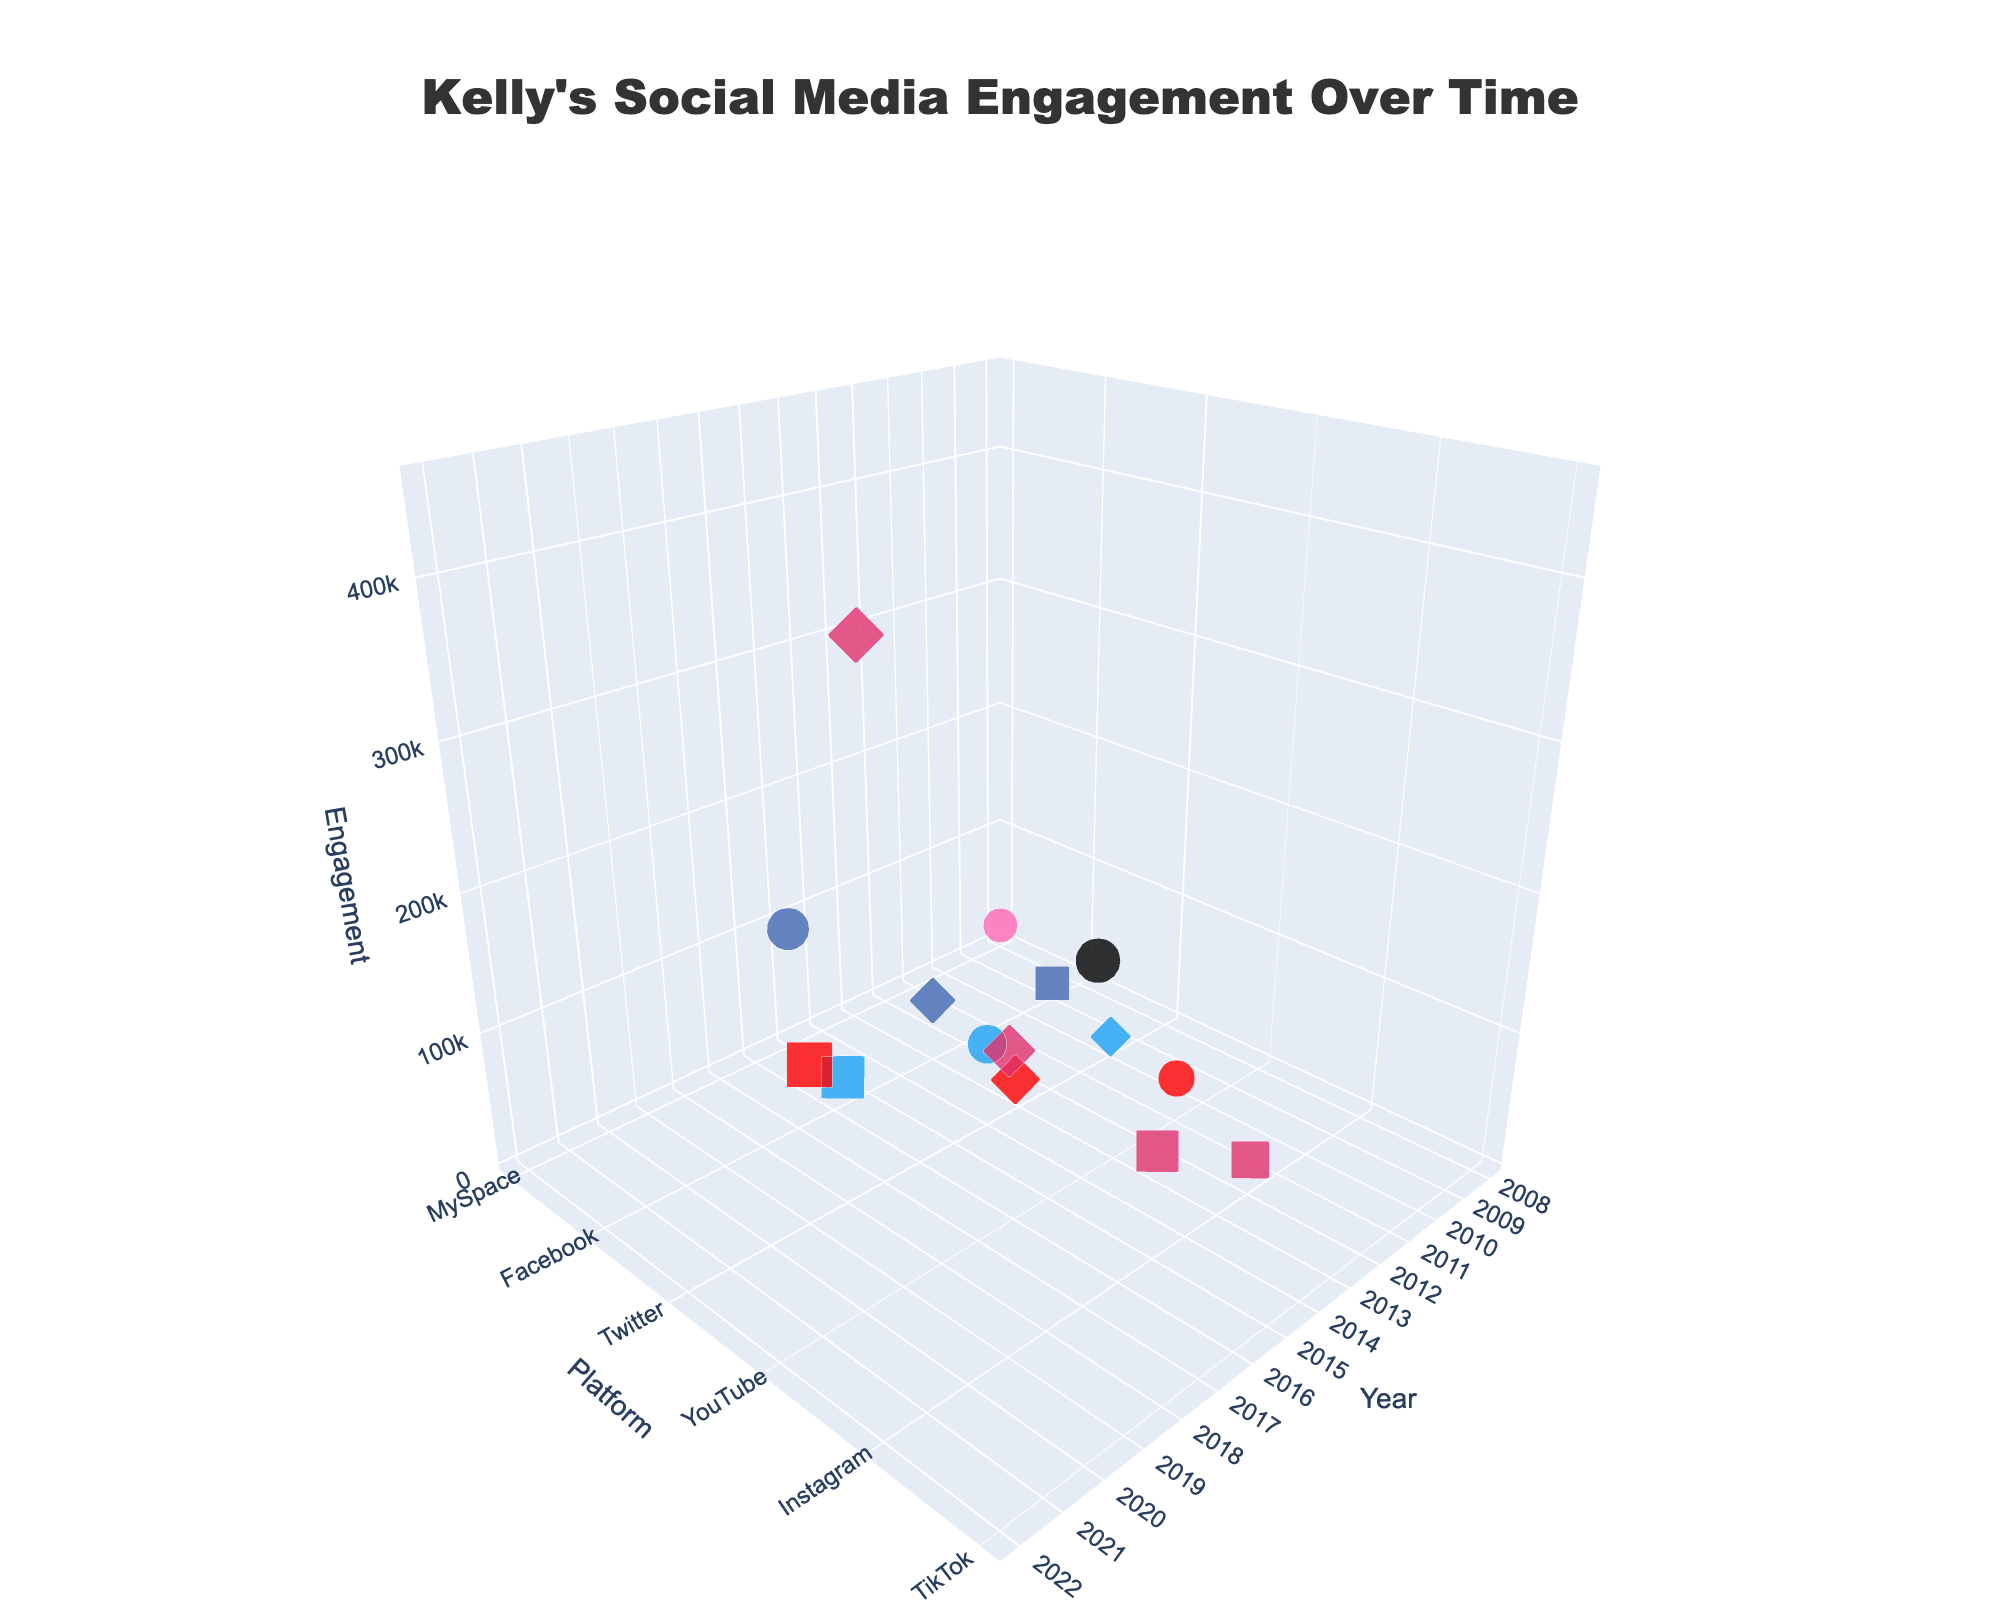How does Kelly's social media engagement in Likes, Comments, and Shares change over the years? To understand the changes, observe each platform's markers and their sizes, colors, and symbols across different years. Note any visible trends in the z-values (represented by marker sizes and vertical positions).
Answer: Changes show a general increase in engagement values, with significant jumps in specific years Which platform, year, and metric combination has the highest engagement? Identify and focus on the marker located at the highest point on the z-axis. Check the hover text or the size and symmetry of the marker for exact details.
Answer: Instagram, 2022, Shares How does the engagement in Comments compare between the years 2012 and 2021? Locate the markers representing Comments for Instagram in 2012 and YouTube in 2021. Compare their z-values using marker sizes and their vertical positions.
Answer: 2021 is significantly higher In which year did Kelly receive the strongest engagement on YouTube? Identify the markers associated with YouTube and then compare their z-values by looking at the sizes and vertical positions of the markers across different years.
Answer: 2021 Which platform shows the earliest recorded data point? Look at the first marker (smallest x-axis value) and check the platform and year from the text information.
Answer: MySpace, 2008 What's the average engagement value for Twitter Likes? Identify Twitter Like markers (circle symbols) and sum their z-values. Then, divide by the number of these markers (Years: 2014 and 2010). Calculation: (60,000 + 12,000) / 2.
Answer: 36,000 Compare the engagement in Shares for Facebook in 2013 with Twitter in 2019. Which is higher? Locate the diamond markers corresponding to Facebook in 2013 and Twitter in 2019, then compare their heights on the z-axis.
Answer: Instagram, 2019 is higher What trend can be observed in Kelly's engagement on Instagram from 2012 to 2022? Look at markers for Instagram in 2012, 2015, 2019, and 2022. Note how the marker sizes and their vertical positions evolve.
Answer: Increasing trend What is the color coding used for different platforms? Examine the color of markers and match them with the platforms as described in the figure's legend or hover text. For example, Instagram is typically pink.
Answer: MySpace: Pink, Facebook: Blue, Twitter: Light Blue, YouTube: Red, Instagram: Pink, TikTok: Black 